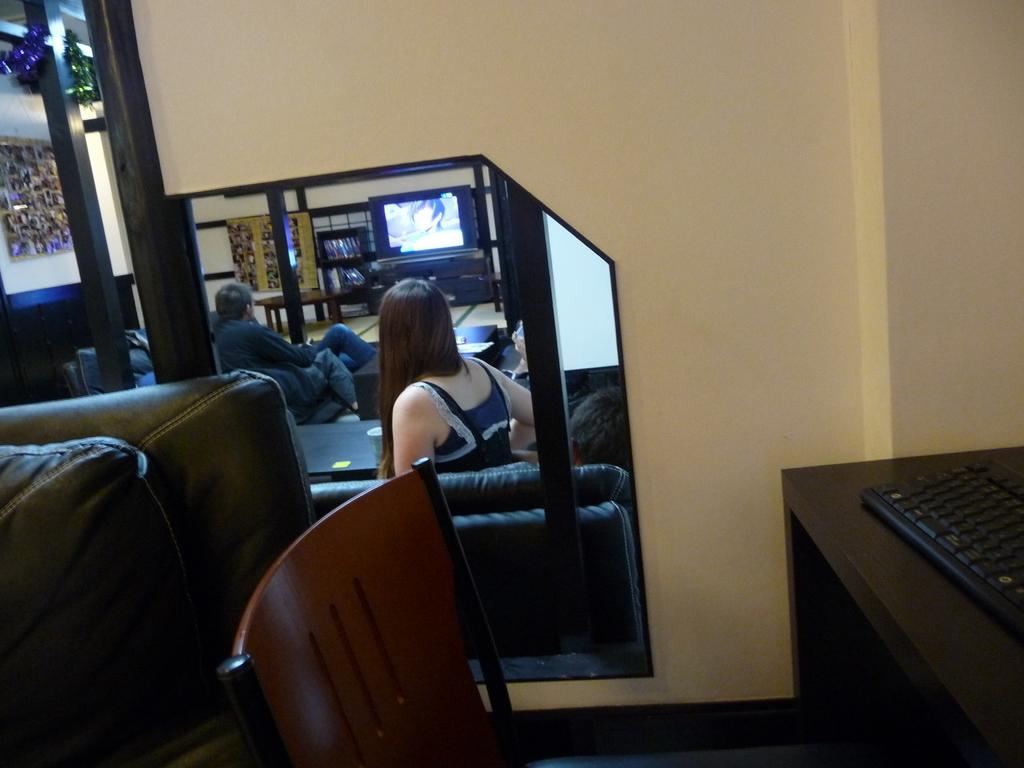Can you describe this image briefly? As we can see in the image, there is a mirror. In mirror there are two persons sitting on sofa and watching television and there is a cream color wall over here and on table there is a keyboard. 